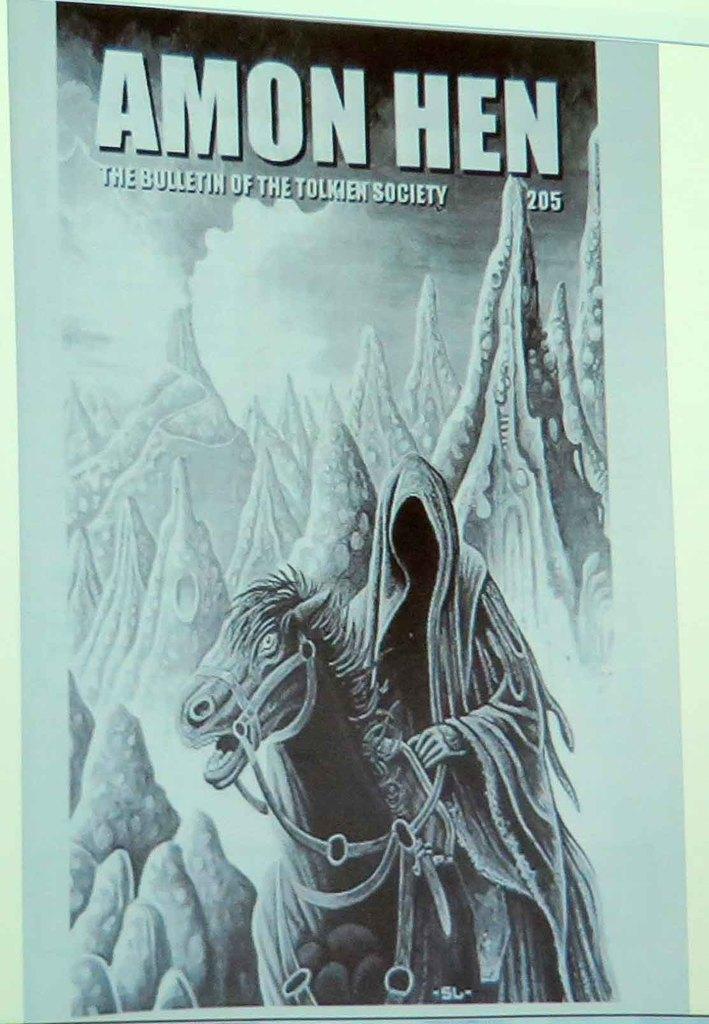How would you summarize this image in a sentence or two? This image consists of a poster. In which there is a horse and a man. In the background, it looks like mountains. At the top, there is a text. 